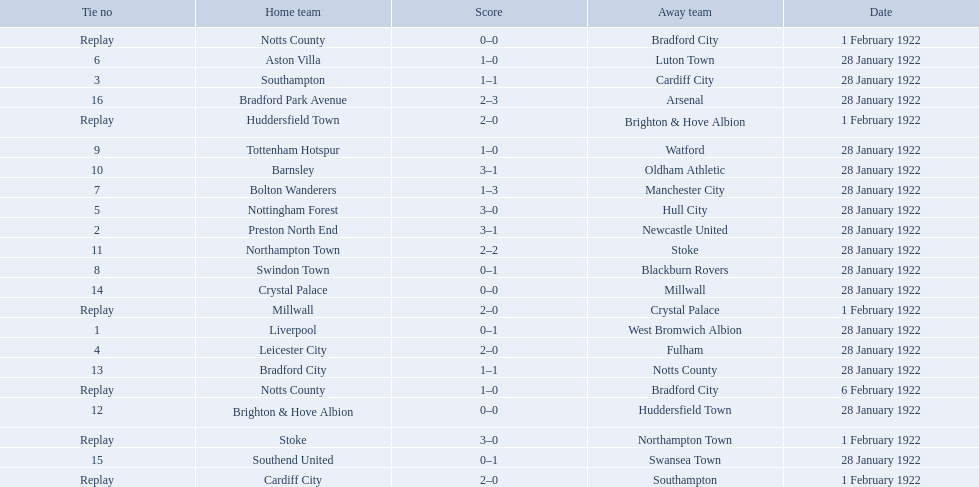What was the score in the aston villa game? 1–0. Which other team had an identical score? Tottenham Hotspur. 